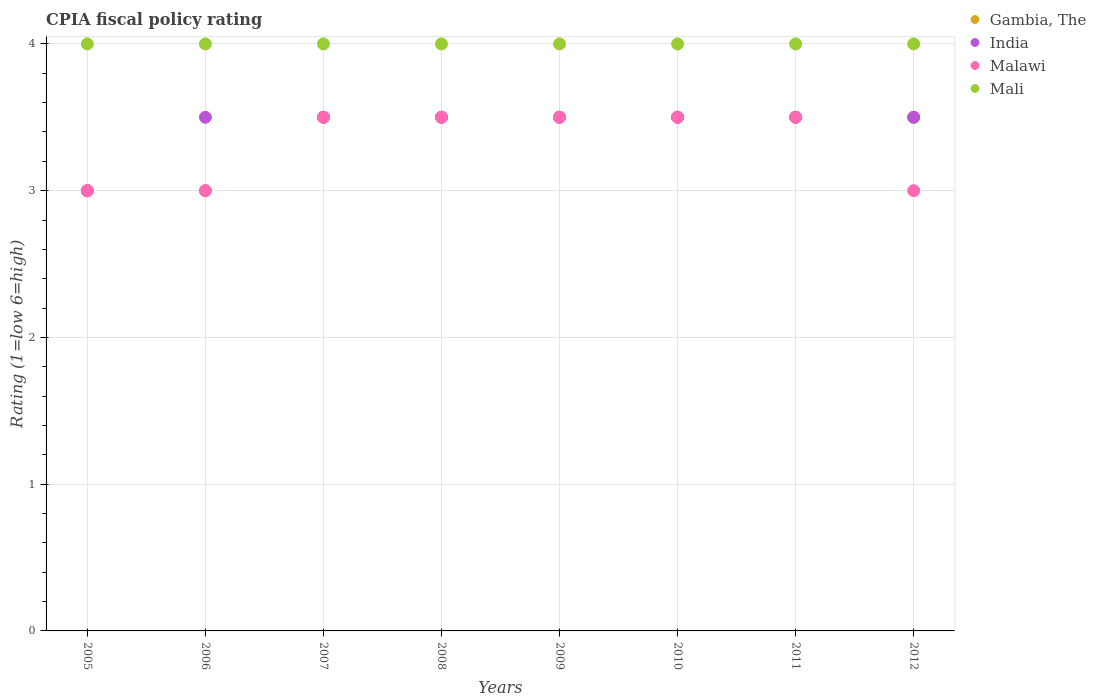What is the CPIA rating in India in 2007?
Offer a very short reply. 3.5. Across all years, what is the minimum CPIA rating in India?
Provide a succinct answer. 3. In which year was the CPIA rating in Mali maximum?
Keep it short and to the point. 2005. In which year was the CPIA rating in India minimum?
Your answer should be very brief. 2005. What is the total CPIA rating in Malawi in the graph?
Offer a terse response. 26.5. What is the difference between the CPIA rating in Malawi in 2007 and the CPIA rating in Mali in 2008?
Make the answer very short. -0.5. What is the average CPIA rating in India per year?
Provide a succinct answer. 3.44. In the year 2008, what is the difference between the CPIA rating in Mali and CPIA rating in India?
Provide a succinct answer. 0.5. What is the ratio of the CPIA rating in Gambia, The in 2007 to that in 2009?
Your answer should be very brief. 1. Is the difference between the CPIA rating in Mali in 2005 and 2011 greater than the difference between the CPIA rating in India in 2005 and 2011?
Offer a terse response. Yes. What is the difference between the highest and the second highest CPIA rating in Mali?
Provide a short and direct response. 0. What is the difference between the highest and the lowest CPIA rating in India?
Your answer should be compact. 0.5. Is it the case that in every year, the sum of the CPIA rating in Mali and CPIA rating in Gambia, The  is greater than the CPIA rating in Malawi?
Your response must be concise. Yes. Does the CPIA rating in India monotonically increase over the years?
Provide a succinct answer. No. Is the CPIA rating in Mali strictly greater than the CPIA rating in Gambia, The over the years?
Provide a succinct answer. Yes. Is the CPIA rating in Mali strictly less than the CPIA rating in India over the years?
Offer a very short reply. No. How many dotlines are there?
Make the answer very short. 4. How many years are there in the graph?
Your answer should be very brief. 8. What is the difference between two consecutive major ticks on the Y-axis?
Your answer should be very brief. 1. Are the values on the major ticks of Y-axis written in scientific E-notation?
Make the answer very short. No. Does the graph contain any zero values?
Provide a short and direct response. No. What is the title of the graph?
Your answer should be compact. CPIA fiscal policy rating. What is the label or title of the X-axis?
Your answer should be very brief. Years. What is the label or title of the Y-axis?
Your answer should be very brief. Rating (1=low 6=high). What is the Rating (1=low 6=high) of Gambia, The in 2005?
Keep it short and to the point. 3. What is the Rating (1=low 6=high) of India in 2005?
Provide a short and direct response. 3. What is the Rating (1=low 6=high) of Malawi in 2005?
Give a very brief answer. 3. What is the Rating (1=low 6=high) of Malawi in 2006?
Ensure brevity in your answer.  3. What is the Rating (1=low 6=high) in Mali in 2006?
Offer a very short reply. 4. What is the Rating (1=low 6=high) of Gambia, The in 2007?
Provide a succinct answer. 3.5. What is the Rating (1=low 6=high) in Malawi in 2007?
Offer a very short reply. 3.5. What is the Rating (1=low 6=high) of Gambia, The in 2008?
Ensure brevity in your answer.  3.5. What is the Rating (1=low 6=high) in India in 2010?
Ensure brevity in your answer.  3.5. What is the Rating (1=low 6=high) in Malawi in 2010?
Offer a terse response. 3.5. What is the Rating (1=low 6=high) in India in 2011?
Offer a very short reply. 3.5. What is the Rating (1=low 6=high) of India in 2012?
Offer a very short reply. 3.5. What is the Rating (1=low 6=high) of Malawi in 2012?
Your answer should be very brief. 3. What is the Rating (1=low 6=high) in Mali in 2012?
Offer a very short reply. 4. Across all years, what is the maximum Rating (1=low 6=high) in India?
Make the answer very short. 3.5. Across all years, what is the maximum Rating (1=low 6=high) of Malawi?
Keep it short and to the point. 3.5. What is the total Rating (1=low 6=high) of India in the graph?
Your answer should be compact. 27.5. What is the total Rating (1=low 6=high) in Malawi in the graph?
Offer a very short reply. 26.5. What is the total Rating (1=low 6=high) of Mali in the graph?
Your response must be concise. 32. What is the difference between the Rating (1=low 6=high) in Gambia, The in 2005 and that in 2006?
Offer a very short reply. 0. What is the difference between the Rating (1=low 6=high) in Malawi in 2005 and that in 2006?
Make the answer very short. 0. What is the difference between the Rating (1=low 6=high) in Mali in 2005 and that in 2006?
Offer a terse response. 0. What is the difference between the Rating (1=low 6=high) in Gambia, The in 2005 and that in 2007?
Make the answer very short. -0.5. What is the difference between the Rating (1=low 6=high) of Mali in 2005 and that in 2007?
Your response must be concise. 0. What is the difference between the Rating (1=low 6=high) of Gambia, The in 2005 and that in 2008?
Provide a succinct answer. -0.5. What is the difference between the Rating (1=low 6=high) of Malawi in 2005 and that in 2008?
Give a very brief answer. -0.5. What is the difference between the Rating (1=low 6=high) in Mali in 2005 and that in 2008?
Give a very brief answer. 0. What is the difference between the Rating (1=low 6=high) in Gambia, The in 2005 and that in 2009?
Ensure brevity in your answer.  -0.5. What is the difference between the Rating (1=low 6=high) of India in 2005 and that in 2009?
Your response must be concise. -0.5. What is the difference between the Rating (1=low 6=high) in Gambia, The in 2005 and that in 2010?
Provide a short and direct response. -0.5. What is the difference between the Rating (1=low 6=high) in Mali in 2005 and that in 2010?
Give a very brief answer. 0. What is the difference between the Rating (1=low 6=high) of Gambia, The in 2005 and that in 2011?
Provide a short and direct response. -0.5. What is the difference between the Rating (1=low 6=high) in Malawi in 2005 and that in 2011?
Your answer should be very brief. -0.5. What is the difference between the Rating (1=low 6=high) of Mali in 2005 and that in 2011?
Offer a very short reply. 0. What is the difference between the Rating (1=low 6=high) in Malawi in 2005 and that in 2012?
Your answer should be compact. 0. What is the difference between the Rating (1=low 6=high) in Mali in 2005 and that in 2012?
Your response must be concise. 0. What is the difference between the Rating (1=low 6=high) in India in 2006 and that in 2007?
Give a very brief answer. 0. What is the difference between the Rating (1=low 6=high) of Malawi in 2006 and that in 2007?
Offer a terse response. -0.5. What is the difference between the Rating (1=low 6=high) of Mali in 2006 and that in 2007?
Your answer should be compact. 0. What is the difference between the Rating (1=low 6=high) of Gambia, The in 2006 and that in 2008?
Provide a short and direct response. -0.5. What is the difference between the Rating (1=low 6=high) in Mali in 2006 and that in 2008?
Provide a succinct answer. 0. What is the difference between the Rating (1=low 6=high) of India in 2006 and that in 2009?
Offer a terse response. 0. What is the difference between the Rating (1=low 6=high) of Gambia, The in 2006 and that in 2011?
Offer a very short reply. -0.5. What is the difference between the Rating (1=low 6=high) in India in 2006 and that in 2011?
Ensure brevity in your answer.  0. What is the difference between the Rating (1=low 6=high) of Malawi in 2006 and that in 2011?
Provide a succinct answer. -0.5. What is the difference between the Rating (1=low 6=high) in Gambia, The in 2006 and that in 2012?
Make the answer very short. -0.5. What is the difference between the Rating (1=low 6=high) in India in 2006 and that in 2012?
Provide a short and direct response. 0. What is the difference between the Rating (1=low 6=high) in Gambia, The in 2007 and that in 2008?
Your answer should be compact. 0. What is the difference between the Rating (1=low 6=high) in Mali in 2007 and that in 2008?
Make the answer very short. 0. What is the difference between the Rating (1=low 6=high) in Malawi in 2007 and that in 2009?
Ensure brevity in your answer.  0. What is the difference between the Rating (1=low 6=high) in Mali in 2007 and that in 2009?
Your answer should be very brief. 0. What is the difference between the Rating (1=low 6=high) of Mali in 2007 and that in 2010?
Provide a succinct answer. 0. What is the difference between the Rating (1=low 6=high) of Mali in 2007 and that in 2011?
Offer a very short reply. 0. What is the difference between the Rating (1=low 6=high) in Malawi in 2007 and that in 2012?
Provide a short and direct response. 0.5. What is the difference between the Rating (1=low 6=high) of Gambia, The in 2008 and that in 2009?
Your answer should be very brief. 0. What is the difference between the Rating (1=low 6=high) in Mali in 2008 and that in 2009?
Provide a short and direct response. 0. What is the difference between the Rating (1=low 6=high) of Gambia, The in 2008 and that in 2010?
Give a very brief answer. 0. What is the difference between the Rating (1=low 6=high) in India in 2008 and that in 2010?
Your answer should be very brief. 0. What is the difference between the Rating (1=low 6=high) of Malawi in 2008 and that in 2010?
Keep it short and to the point. 0. What is the difference between the Rating (1=low 6=high) of Mali in 2008 and that in 2010?
Your response must be concise. 0. What is the difference between the Rating (1=low 6=high) in Gambia, The in 2008 and that in 2011?
Your response must be concise. 0. What is the difference between the Rating (1=low 6=high) of Malawi in 2008 and that in 2011?
Keep it short and to the point. 0. What is the difference between the Rating (1=low 6=high) in Mali in 2008 and that in 2011?
Offer a very short reply. 0. What is the difference between the Rating (1=low 6=high) in Malawi in 2008 and that in 2012?
Provide a short and direct response. 0.5. What is the difference between the Rating (1=low 6=high) in Gambia, The in 2009 and that in 2010?
Make the answer very short. 0. What is the difference between the Rating (1=low 6=high) of Mali in 2009 and that in 2010?
Offer a very short reply. 0. What is the difference between the Rating (1=low 6=high) of India in 2009 and that in 2011?
Offer a terse response. 0. What is the difference between the Rating (1=low 6=high) of Malawi in 2009 and that in 2011?
Provide a succinct answer. 0. What is the difference between the Rating (1=low 6=high) of Malawi in 2009 and that in 2012?
Provide a short and direct response. 0.5. What is the difference between the Rating (1=low 6=high) of Gambia, The in 2010 and that in 2011?
Keep it short and to the point. 0. What is the difference between the Rating (1=low 6=high) of India in 2010 and that in 2011?
Provide a short and direct response. 0. What is the difference between the Rating (1=low 6=high) of Gambia, The in 2010 and that in 2012?
Keep it short and to the point. 0. What is the difference between the Rating (1=low 6=high) in Malawi in 2010 and that in 2012?
Offer a terse response. 0.5. What is the difference between the Rating (1=low 6=high) in India in 2011 and that in 2012?
Give a very brief answer. 0. What is the difference between the Rating (1=low 6=high) of Mali in 2011 and that in 2012?
Keep it short and to the point. 0. What is the difference between the Rating (1=low 6=high) in Gambia, The in 2005 and the Rating (1=low 6=high) in Malawi in 2006?
Your answer should be very brief. 0. What is the difference between the Rating (1=low 6=high) of Gambia, The in 2005 and the Rating (1=low 6=high) of Mali in 2006?
Your response must be concise. -1. What is the difference between the Rating (1=low 6=high) of India in 2005 and the Rating (1=low 6=high) of Mali in 2006?
Provide a short and direct response. -1. What is the difference between the Rating (1=low 6=high) in Malawi in 2005 and the Rating (1=low 6=high) in Mali in 2006?
Your answer should be compact. -1. What is the difference between the Rating (1=low 6=high) in Gambia, The in 2005 and the Rating (1=low 6=high) in India in 2007?
Offer a terse response. -0.5. What is the difference between the Rating (1=low 6=high) in Gambia, The in 2005 and the Rating (1=low 6=high) in Malawi in 2007?
Provide a succinct answer. -0.5. What is the difference between the Rating (1=low 6=high) of India in 2005 and the Rating (1=low 6=high) of Mali in 2007?
Your answer should be compact. -1. What is the difference between the Rating (1=low 6=high) in Malawi in 2005 and the Rating (1=low 6=high) in Mali in 2007?
Your response must be concise. -1. What is the difference between the Rating (1=low 6=high) of India in 2005 and the Rating (1=low 6=high) of Malawi in 2008?
Your response must be concise. -0.5. What is the difference between the Rating (1=low 6=high) in Gambia, The in 2005 and the Rating (1=low 6=high) in Mali in 2009?
Provide a short and direct response. -1. What is the difference between the Rating (1=low 6=high) in India in 2005 and the Rating (1=low 6=high) in Malawi in 2009?
Make the answer very short. -0.5. What is the difference between the Rating (1=low 6=high) in India in 2005 and the Rating (1=low 6=high) in Mali in 2009?
Your answer should be very brief. -1. What is the difference between the Rating (1=low 6=high) in Malawi in 2005 and the Rating (1=low 6=high) in Mali in 2009?
Your response must be concise. -1. What is the difference between the Rating (1=low 6=high) in Gambia, The in 2005 and the Rating (1=low 6=high) in India in 2010?
Provide a short and direct response. -0.5. What is the difference between the Rating (1=low 6=high) of Gambia, The in 2005 and the Rating (1=low 6=high) of Mali in 2010?
Offer a terse response. -1. What is the difference between the Rating (1=low 6=high) in India in 2005 and the Rating (1=low 6=high) in Malawi in 2010?
Offer a terse response. -0.5. What is the difference between the Rating (1=low 6=high) of Malawi in 2005 and the Rating (1=low 6=high) of Mali in 2010?
Give a very brief answer. -1. What is the difference between the Rating (1=low 6=high) in Gambia, The in 2005 and the Rating (1=low 6=high) in Malawi in 2011?
Your answer should be compact. -0.5. What is the difference between the Rating (1=low 6=high) of Gambia, The in 2005 and the Rating (1=low 6=high) of Mali in 2011?
Your response must be concise. -1. What is the difference between the Rating (1=low 6=high) in India in 2005 and the Rating (1=low 6=high) in Malawi in 2011?
Keep it short and to the point. -0.5. What is the difference between the Rating (1=low 6=high) in Malawi in 2005 and the Rating (1=low 6=high) in Mali in 2011?
Your answer should be very brief. -1. What is the difference between the Rating (1=low 6=high) in Gambia, The in 2005 and the Rating (1=low 6=high) in Malawi in 2012?
Provide a succinct answer. 0. What is the difference between the Rating (1=low 6=high) in Gambia, The in 2005 and the Rating (1=low 6=high) in Mali in 2012?
Provide a succinct answer. -1. What is the difference between the Rating (1=low 6=high) in Gambia, The in 2006 and the Rating (1=low 6=high) in Mali in 2007?
Ensure brevity in your answer.  -1. What is the difference between the Rating (1=low 6=high) of India in 2006 and the Rating (1=low 6=high) of Malawi in 2007?
Make the answer very short. 0. What is the difference between the Rating (1=low 6=high) in India in 2006 and the Rating (1=low 6=high) in Mali in 2007?
Ensure brevity in your answer.  -0.5. What is the difference between the Rating (1=low 6=high) of Malawi in 2006 and the Rating (1=low 6=high) of Mali in 2007?
Your response must be concise. -1. What is the difference between the Rating (1=low 6=high) in Gambia, The in 2006 and the Rating (1=low 6=high) in India in 2008?
Offer a very short reply. -0.5. What is the difference between the Rating (1=low 6=high) in Gambia, The in 2006 and the Rating (1=low 6=high) in Malawi in 2008?
Provide a short and direct response. -0.5. What is the difference between the Rating (1=low 6=high) of Gambia, The in 2006 and the Rating (1=low 6=high) of India in 2009?
Provide a succinct answer. -0.5. What is the difference between the Rating (1=low 6=high) of Gambia, The in 2006 and the Rating (1=low 6=high) of Mali in 2009?
Provide a succinct answer. -1. What is the difference between the Rating (1=low 6=high) of India in 2006 and the Rating (1=low 6=high) of Mali in 2009?
Provide a short and direct response. -0.5. What is the difference between the Rating (1=low 6=high) of Gambia, The in 2006 and the Rating (1=low 6=high) of Mali in 2010?
Give a very brief answer. -1. What is the difference between the Rating (1=low 6=high) in India in 2006 and the Rating (1=low 6=high) in Mali in 2010?
Offer a very short reply. -0.5. What is the difference between the Rating (1=low 6=high) of Malawi in 2006 and the Rating (1=low 6=high) of Mali in 2010?
Provide a succinct answer. -1. What is the difference between the Rating (1=low 6=high) in Gambia, The in 2006 and the Rating (1=low 6=high) in Malawi in 2011?
Your answer should be very brief. -0.5. What is the difference between the Rating (1=low 6=high) of India in 2006 and the Rating (1=low 6=high) of Mali in 2011?
Provide a succinct answer. -0.5. What is the difference between the Rating (1=low 6=high) of Gambia, The in 2006 and the Rating (1=low 6=high) of Malawi in 2012?
Your answer should be very brief. 0. What is the difference between the Rating (1=low 6=high) in Gambia, The in 2007 and the Rating (1=low 6=high) in India in 2008?
Provide a succinct answer. 0. What is the difference between the Rating (1=low 6=high) in Gambia, The in 2007 and the Rating (1=low 6=high) in Malawi in 2008?
Provide a succinct answer. 0. What is the difference between the Rating (1=low 6=high) in India in 2007 and the Rating (1=low 6=high) in Malawi in 2008?
Your response must be concise. 0. What is the difference between the Rating (1=low 6=high) of India in 2007 and the Rating (1=low 6=high) of Mali in 2008?
Provide a short and direct response. -0.5. What is the difference between the Rating (1=low 6=high) in Malawi in 2007 and the Rating (1=low 6=high) in Mali in 2008?
Ensure brevity in your answer.  -0.5. What is the difference between the Rating (1=low 6=high) of Gambia, The in 2007 and the Rating (1=low 6=high) of Malawi in 2009?
Give a very brief answer. 0. What is the difference between the Rating (1=low 6=high) of Gambia, The in 2007 and the Rating (1=low 6=high) of Malawi in 2010?
Offer a very short reply. 0. What is the difference between the Rating (1=low 6=high) in India in 2007 and the Rating (1=low 6=high) in Mali in 2010?
Offer a terse response. -0.5. What is the difference between the Rating (1=low 6=high) of Malawi in 2007 and the Rating (1=low 6=high) of Mali in 2010?
Your response must be concise. -0.5. What is the difference between the Rating (1=low 6=high) in Gambia, The in 2007 and the Rating (1=low 6=high) in Mali in 2011?
Your answer should be compact. -0.5. What is the difference between the Rating (1=low 6=high) of India in 2007 and the Rating (1=low 6=high) of Malawi in 2011?
Offer a terse response. 0. What is the difference between the Rating (1=low 6=high) of India in 2007 and the Rating (1=low 6=high) of Mali in 2011?
Ensure brevity in your answer.  -0.5. What is the difference between the Rating (1=low 6=high) in Gambia, The in 2007 and the Rating (1=low 6=high) in Malawi in 2012?
Your answer should be compact. 0.5. What is the difference between the Rating (1=low 6=high) of Gambia, The in 2008 and the Rating (1=low 6=high) of Mali in 2009?
Ensure brevity in your answer.  -0.5. What is the difference between the Rating (1=low 6=high) of India in 2008 and the Rating (1=low 6=high) of Mali in 2009?
Your answer should be compact. -0.5. What is the difference between the Rating (1=low 6=high) of Malawi in 2008 and the Rating (1=low 6=high) of Mali in 2009?
Offer a very short reply. -0.5. What is the difference between the Rating (1=low 6=high) in Gambia, The in 2008 and the Rating (1=low 6=high) in India in 2010?
Keep it short and to the point. 0. What is the difference between the Rating (1=low 6=high) of Gambia, The in 2008 and the Rating (1=low 6=high) of Malawi in 2010?
Make the answer very short. 0. What is the difference between the Rating (1=low 6=high) of India in 2008 and the Rating (1=low 6=high) of Mali in 2010?
Offer a very short reply. -0.5. What is the difference between the Rating (1=low 6=high) of Malawi in 2008 and the Rating (1=low 6=high) of Mali in 2010?
Your answer should be very brief. -0.5. What is the difference between the Rating (1=low 6=high) of Gambia, The in 2008 and the Rating (1=low 6=high) of India in 2011?
Your response must be concise. 0. What is the difference between the Rating (1=low 6=high) in Gambia, The in 2008 and the Rating (1=low 6=high) in Malawi in 2011?
Offer a terse response. 0. What is the difference between the Rating (1=low 6=high) in Gambia, The in 2008 and the Rating (1=low 6=high) in Mali in 2011?
Offer a very short reply. -0.5. What is the difference between the Rating (1=low 6=high) in India in 2008 and the Rating (1=low 6=high) in Malawi in 2011?
Offer a terse response. 0. What is the difference between the Rating (1=low 6=high) of Gambia, The in 2008 and the Rating (1=low 6=high) of Mali in 2012?
Keep it short and to the point. -0.5. What is the difference between the Rating (1=low 6=high) in India in 2008 and the Rating (1=low 6=high) in Mali in 2012?
Your answer should be very brief. -0.5. What is the difference between the Rating (1=low 6=high) in Gambia, The in 2009 and the Rating (1=low 6=high) in India in 2010?
Your answer should be very brief. 0. What is the difference between the Rating (1=low 6=high) in Gambia, The in 2009 and the Rating (1=low 6=high) in Malawi in 2010?
Make the answer very short. 0. What is the difference between the Rating (1=low 6=high) of Gambia, The in 2009 and the Rating (1=low 6=high) of Mali in 2010?
Give a very brief answer. -0.5. What is the difference between the Rating (1=low 6=high) in Gambia, The in 2009 and the Rating (1=low 6=high) in Mali in 2011?
Make the answer very short. -0.5. What is the difference between the Rating (1=low 6=high) in India in 2009 and the Rating (1=low 6=high) in Malawi in 2011?
Your answer should be very brief. 0. What is the difference between the Rating (1=low 6=high) of India in 2009 and the Rating (1=low 6=high) of Mali in 2011?
Ensure brevity in your answer.  -0.5. What is the difference between the Rating (1=low 6=high) of Gambia, The in 2009 and the Rating (1=low 6=high) of Malawi in 2012?
Offer a very short reply. 0.5. What is the difference between the Rating (1=low 6=high) of Gambia, The in 2010 and the Rating (1=low 6=high) of Malawi in 2011?
Provide a succinct answer. 0. What is the difference between the Rating (1=low 6=high) of Gambia, The in 2010 and the Rating (1=low 6=high) of Mali in 2011?
Keep it short and to the point. -0.5. What is the difference between the Rating (1=low 6=high) of India in 2010 and the Rating (1=low 6=high) of Malawi in 2011?
Your answer should be compact. 0. What is the difference between the Rating (1=low 6=high) in India in 2010 and the Rating (1=low 6=high) in Mali in 2011?
Your answer should be compact. -0.5. What is the difference between the Rating (1=low 6=high) of Gambia, The in 2011 and the Rating (1=low 6=high) of India in 2012?
Provide a succinct answer. 0. What is the difference between the Rating (1=low 6=high) of Gambia, The in 2011 and the Rating (1=low 6=high) of Malawi in 2012?
Provide a succinct answer. 0.5. What is the difference between the Rating (1=low 6=high) in Malawi in 2011 and the Rating (1=low 6=high) in Mali in 2012?
Keep it short and to the point. -0.5. What is the average Rating (1=low 6=high) of Gambia, The per year?
Keep it short and to the point. 3.38. What is the average Rating (1=low 6=high) of India per year?
Your response must be concise. 3.44. What is the average Rating (1=low 6=high) in Malawi per year?
Your response must be concise. 3.31. In the year 2005, what is the difference between the Rating (1=low 6=high) of Gambia, The and Rating (1=low 6=high) of India?
Make the answer very short. 0. In the year 2005, what is the difference between the Rating (1=low 6=high) of Gambia, The and Rating (1=low 6=high) of Malawi?
Keep it short and to the point. 0. In the year 2005, what is the difference between the Rating (1=low 6=high) of Gambia, The and Rating (1=low 6=high) of Mali?
Provide a succinct answer. -1. In the year 2005, what is the difference between the Rating (1=low 6=high) in India and Rating (1=low 6=high) in Mali?
Offer a terse response. -1. In the year 2006, what is the difference between the Rating (1=low 6=high) of Gambia, The and Rating (1=low 6=high) of India?
Ensure brevity in your answer.  -0.5. In the year 2006, what is the difference between the Rating (1=low 6=high) in Gambia, The and Rating (1=low 6=high) in Mali?
Give a very brief answer. -1. In the year 2007, what is the difference between the Rating (1=low 6=high) of Gambia, The and Rating (1=low 6=high) of India?
Provide a succinct answer. 0. In the year 2007, what is the difference between the Rating (1=low 6=high) of Malawi and Rating (1=low 6=high) of Mali?
Provide a short and direct response. -0.5. In the year 2008, what is the difference between the Rating (1=low 6=high) in Gambia, The and Rating (1=low 6=high) in Malawi?
Keep it short and to the point. 0. In the year 2008, what is the difference between the Rating (1=low 6=high) in India and Rating (1=low 6=high) in Mali?
Offer a very short reply. -0.5. In the year 2008, what is the difference between the Rating (1=low 6=high) of Malawi and Rating (1=low 6=high) of Mali?
Give a very brief answer. -0.5. In the year 2009, what is the difference between the Rating (1=low 6=high) of Gambia, The and Rating (1=low 6=high) of Mali?
Provide a succinct answer. -0.5. In the year 2009, what is the difference between the Rating (1=low 6=high) of India and Rating (1=low 6=high) of Malawi?
Make the answer very short. 0. In the year 2009, what is the difference between the Rating (1=low 6=high) in Malawi and Rating (1=low 6=high) in Mali?
Keep it short and to the point. -0.5. In the year 2010, what is the difference between the Rating (1=low 6=high) of Gambia, The and Rating (1=low 6=high) of India?
Provide a short and direct response. 0. In the year 2010, what is the difference between the Rating (1=low 6=high) of Gambia, The and Rating (1=low 6=high) of Mali?
Your answer should be very brief. -0.5. In the year 2010, what is the difference between the Rating (1=low 6=high) in India and Rating (1=low 6=high) in Malawi?
Keep it short and to the point. 0. In the year 2010, what is the difference between the Rating (1=low 6=high) of India and Rating (1=low 6=high) of Mali?
Give a very brief answer. -0.5. In the year 2011, what is the difference between the Rating (1=low 6=high) in Malawi and Rating (1=low 6=high) in Mali?
Offer a terse response. -0.5. In the year 2012, what is the difference between the Rating (1=low 6=high) in Gambia, The and Rating (1=low 6=high) in India?
Make the answer very short. 0. In the year 2012, what is the difference between the Rating (1=low 6=high) in Gambia, The and Rating (1=low 6=high) in Mali?
Make the answer very short. -0.5. In the year 2012, what is the difference between the Rating (1=low 6=high) of India and Rating (1=low 6=high) of Mali?
Give a very brief answer. -0.5. What is the ratio of the Rating (1=low 6=high) of Gambia, The in 2005 to that in 2006?
Your answer should be compact. 1. What is the ratio of the Rating (1=low 6=high) of India in 2005 to that in 2006?
Your response must be concise. 0.86. What is the ratio of the Rating (1=low 6=high) of Malawi in 2005 to that in 2006?
Keep it short and to the point. 1. What is the ratio of the Rating (1=low 6=high) in India in 2005 to that in 2007?
Keep it short and to the point. 0.86. What is the ratio of the Rating (1=low 6=high) in Malawi in 2005 to that in 2007?
Provide a succinct answer. 0.86. What is the ratio of the Rating (1=low 6=high) in Mali in 2005 to that in 2007?
Give a very brief answer. 1. What is the ratio of the Rating (1=low 6=high) of Gambia, The in 2005 to that in 2008?
Provide a short and direct response. 0.86. What is the ratio of the Rating (1=low 6=high) in Malawi in 2005 to that in 2008?
Provide a succinct answer. 0.86. What is the ratio of the Rating (1=low 6=high) of Gambia, The in 2005 to that in 2009?
Ensure brevity in your answer.  0.86. What is the ratio of the Rating (1=low 6=high) of Malawi in 2005 to that in 2009?
Make the answer very short. 0.86. What is the ratio of the Rating (1=low 6=high) in Mali in 2005 to that in 2009?
Your response must be concise. 1. What is the ratio of the Rating (1=low 6=high) in India in 2005 to that in 2011?
Your answer should be very brief. 0.86. What is the ratio of the Rating (1=low 6=high) in Gambia, The in 2005 to that in 2012?
Provide a short and direct response. 0.86. What is the ratio of the Rating (1=low 6=high) of Mali in 2005 to that in 2012?
Give a very brief answer. 1. What is the ratio of the Rating (1=low 6=high) of India in 2006 to that in 2007?
Provide a short and direct response. 1. What is the ratio of the Rating (1=low 6=high) of Malawi in 2006 to that in 2007?
Your answer should be very brief. 0.86. What is the ratio of the Rating (1=low 6=high) of Mali in 2006 to that in 2009?
Provide a succinct answer. 1. What is the ratio of the Rating (1=low 6=high) of Gambia, The in 2006 to that in 2010?
Make the answer very short. 0.86. What is the ratio of the Rating (1=low 6=high) in Malawi in 2006 to that in 2010?
Offer a terse response. 0.86. What is the ratio of the Rating (1=low 6=high) of Mali in 2006 to that in 2010?
Keep it short and to the point. 1. What is the ratio of the Rating (1=low 6=high) in Gambia, The in 2006 to that in 2011?
Offer a terse response. 0.86. What is the ratio of the Rating (1=low 6=high) in Gambia, The in 2006 to that in 2012?
Make the answer very short. 0.86. What is the ratio of the Rating (1=low 6=high) of Malawi in 2006 to that in 2012?
Ensure brevity in your answer.  1. What is the ratio of the Rating (1=low 6=high) in India in 2007 to that in 2008?
Give a very brief answer. 1. What is the ratio of the Rating (1=low 6=high) of Gambia, The in 2007 to that in 2009?
Your answer should be very brief. 1. What is the ratio of the Rating (1=low 6=high) of Malawi in 2007 to that in 2009?
Ensure brevity in your answer.  1. What is the ratio of the Rating (1=low 6=high) of Mali in 2007 to that in 2009?
Give a very brief answer. 1. What is the ratio of the Rating (1=low 6=high) of India in 2007 to that in 2010?
Give a very brief answer. 1. What is the ratio of the Rating (1=low 6=high) in Malawi in 2007 to that in 2010?
Your response must be concise. 1. What is the ratio of the Rating (1=low 6=high) of Mali in 2007 to that in 2010?
Your response must be concise. 1. What is the ratio of the Rating (1=low 6=high) of Gambia, The in 2007 to that in 2011?
Provide a short and direct response. 1. What is the ratio of the Rating (1=low 6=high) of India in 2007 to that in 2011?
Keep it short and to the point. 1. What is the ratio of the Rating (1=low 6=high) of Malawi in 2007 to that in 2011?
Offer a terse response. 1. What is the ratio of the Rating (1=low 6=high) in India in 2007 to that in 2012?
Provide a succinct answer. 1. What is the ratio of the Rating (1=low 6=high) in Mali in 2008 to that in 2009?
Provide a succinct answer. 1. What is the ratio of the Rating (1=low 6=high) of Malawi in 2008 to that in 2010?
Provide a short and direct response. 1. What is the ratio of the Rating (1=low 6=high) in Mali in 2008 to that in 2010?
Offer a very short reply. 1. What is the ratio of the Rating (1=low 6=high) in India in 2008 to that in 2011?
Offer a very short reply. 1. What is the ratio of the Rating (1=low 6=high) of Malawi in 2008 to that in 2011?
Your response must be concise. 1. What is the ratio of the Rating (1=low 6=high) of Mali in 2008 to that in 2011?
Keep it short and to the point. 1. What is the ratio of the Rating (1=low 6=high) of Gambia, The in 2008 to that in 2012?
Your response must be concise. 1. What is the ratio of the Rating (1=low 6=high) of Malawi in 2008 to that in 2012?
Keep it short and to the point. 1.17. What is the ratio of the Rating (1=low 6=high) of Gambia, The in 2009 to that in 2010?
Offer a very short reply. 1. What is the ratio of the Rating (1=low 6=high) in India in 2009 to that in 2010?
Your response must be concise. 1. What is the ratio of the Rating (1=low 6=high) in Mali in 2009 to that in 2010?
Keep it short and to the point. 1. What is the ratio of the Rating (1=low 6=high) of Gambia, The in 2009 to that in 2011?
Your response must be concise. 1. What is the ratio of the Rating (1=low 6=high) in India in 2009 to that in 2011?
Your response must be concise. 1. What is the ratio of the Rating (1=low 6=high) of Malawi in 2009 to that in 2011?
Provide a succinct answer. 1. What is the ratio of the Rating (1=low 6=high) in Mali in 2009 to that in 2011?
Your answer should be very brief. 1. What is the ratio of the Rating (1=low 6=high) in Gambia, The in 2009 to that in 2012?
Provide a succinct answer. 1. What is the ratio of the Rating (1=low 6=high) in India in 2009 to that in 2012?
Ensure brevity in your answer.  1. What is the ratio of the Rating (1=low 6=high) of Mali in 2009 to that in 2012?
Keep it short and to the point. 1. What is the ratio of the Rating (1=low 6=high) in Malawi in 2010 to that in 2011?
Your response must be concise. 1. What is the ratio of the Rating (1=low 6=high) of Mali in 2010 to that in 2011?
Your response must be concise. 1. What is the ratio of the Rating (1=low 6=high) in India in 2010 to that in 2012?
Ensure brevity in your answer.  1. What is the ratio of the Rating (1=low 6=high) of Mali in 2010 to that in 2012?
Provide a short and direct response. 1. What is the ratio of the Rating (1=low 6=high) of Gambia, The in 2011 to that in 2012?
Give a very brief answer. 1. What is the difference between the highest and the second highest Rating (1=low 6=high) of Gambia, The?
Your answer should be compact. 0. What is the difference between the highest and the second highest Rating (1=low 6=high) in Mali?
Give a very brief answer. 0. What is the difference between the highest and the lowest Rating (1=low 6=high) in Gambia, The?
Your answer should be very brief. 0.5. What is the difference between the highest and the lowest Rating (1=low 6=high) in Mali?
Keep it short and to the point. 0. 